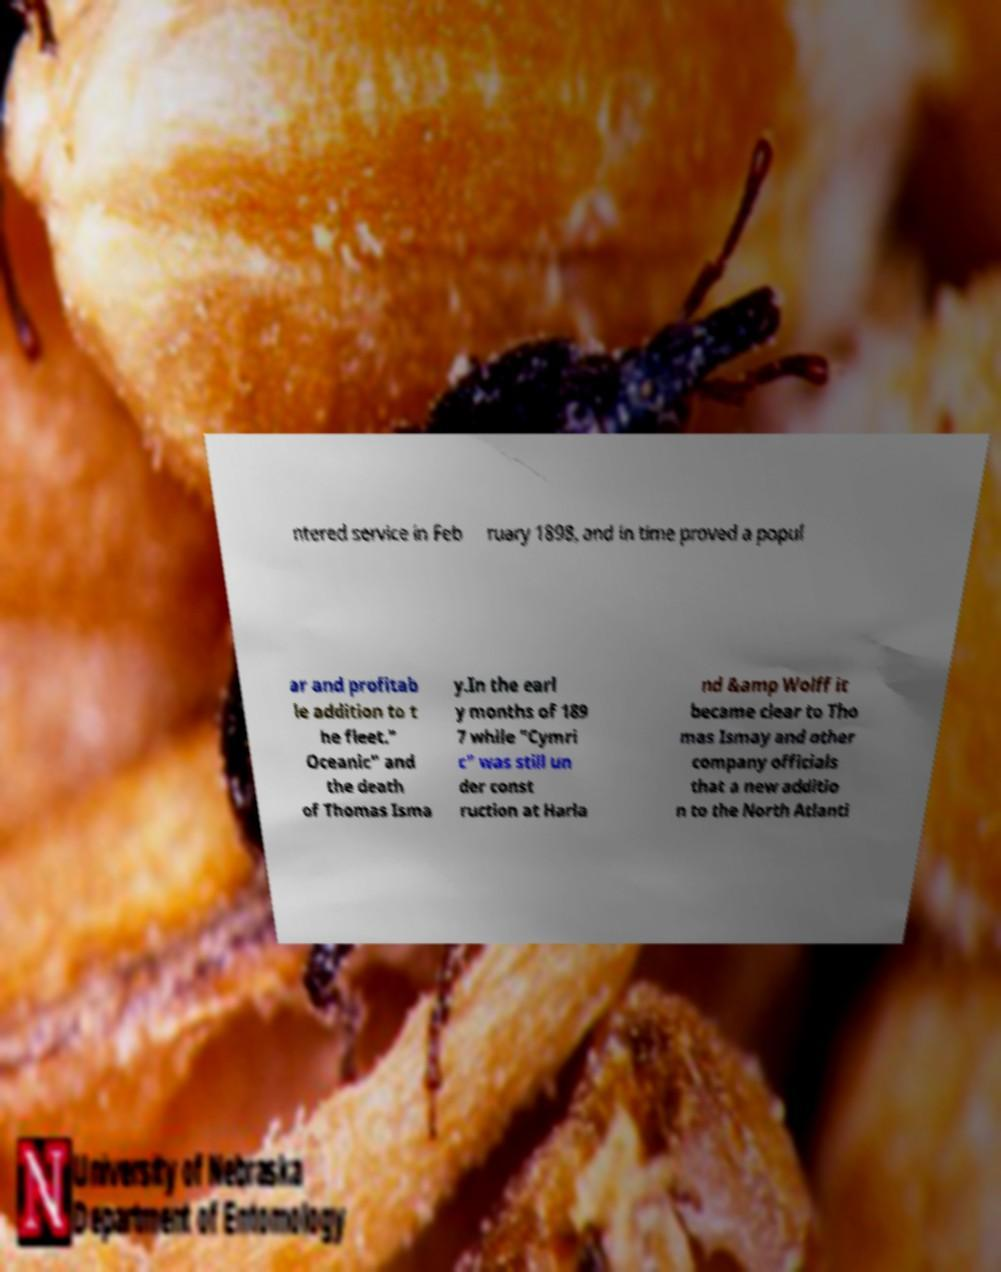Could you assist in decoding the text presented in this image and type it out clearly? ntered service in Feb ruary 1898, and in time proved a popul ar and profitab le addition to t he fleet." Oceanic" and the death of Thomas Isma y.In the earl y months of 189 7 while "Cymri c" was still un der const ruction at Harla nd &amp Wolff it became clear to Tho mas Ismay and other company officials that a new additio n to the North Atlanti 